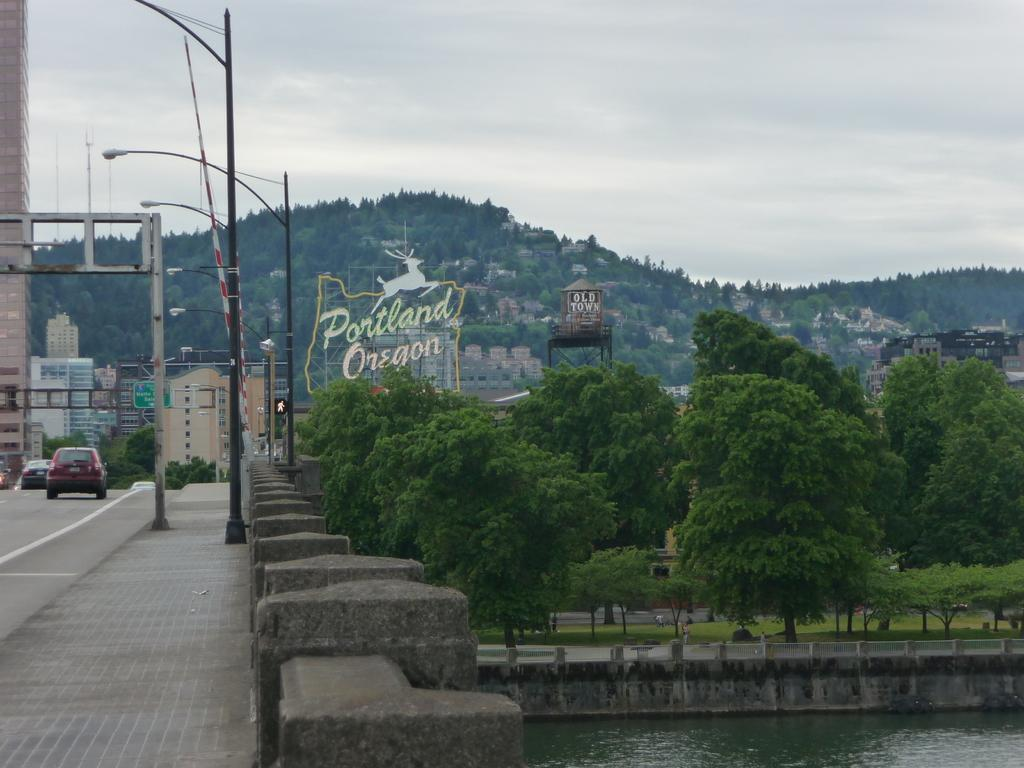What type of vehicles can be seen on the road in the image? There are cars on the road in the image. What additional feature can be found alongside the road? There is a footpath in the image. What structures are present in the image? There are poles, buildings, and name boards in the image. What natural elements can be seen in the image? There are trees, mountains, water, grass, and clouds in the image. What type of lighting is present in the image? There are lights in the image. What can be seen in the background of the image? The sky is visible in the background of the image, with clouds present. What type of paper is being used to construct the space station in the image? There is no space station or paper present in the image. How many quivers can be seen on the grass in the image? There are no quivers present in the image. 